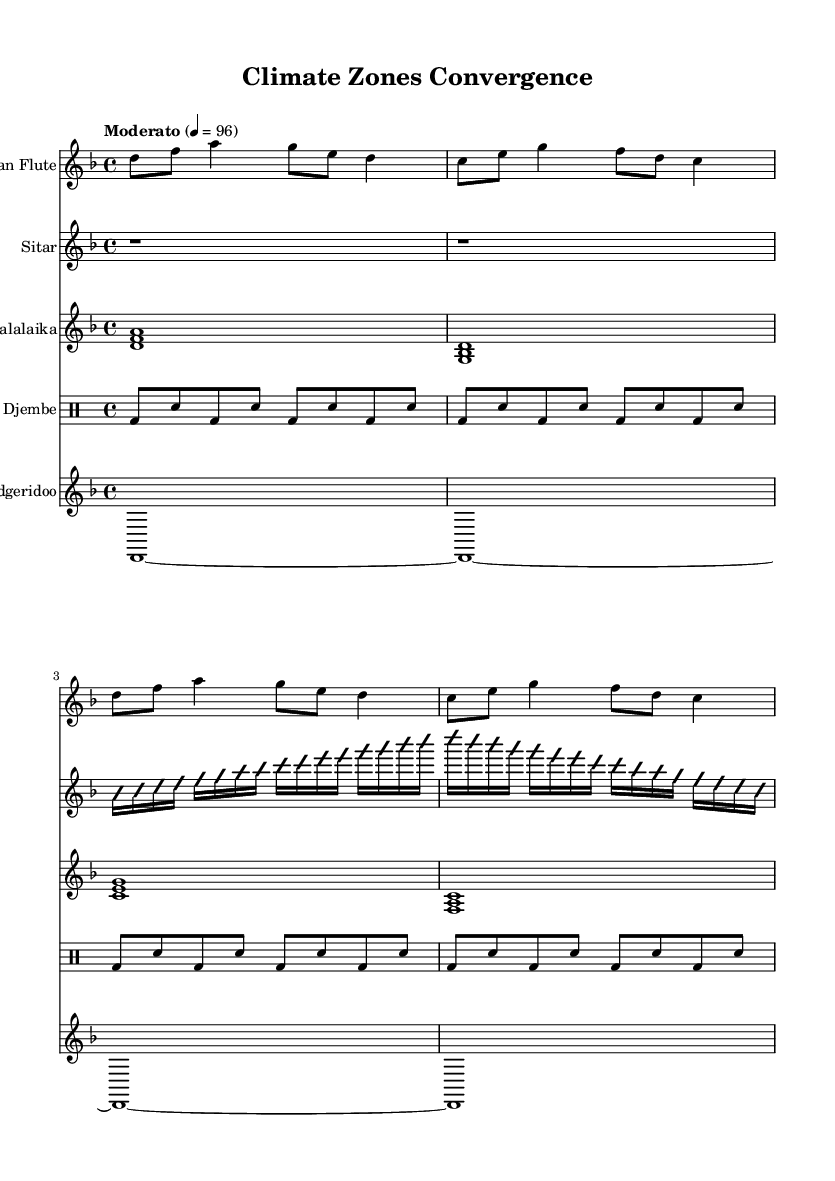What is the key signature of this music? The key signature is D minor, which contains one flat (B flat).
Answer: D minor What is the time signature of the piece? The time signature is 4/4, meaning there are four beats in each measure.
Answer: 4/4 What is the tempo marking indicated in the sheet music? The tempo is marked as "Moderato," which typically indicates a moderate speed.
Answer: Moderato How many different instruments are used in this composition? There are five instruments: pan flute, sitar, balalaika, djembe, and didgeridoo.
Answer: Five Which instrument has a drum pattern, and what is it called? The djembe has a specified drum pattern, identified by the notation unique to percussion instruments.
Answer: Djembe What texture does the sitar part suggest in the music? The sitar part indicates an improvisational texture, as denoted by the "improvisationOn" and "improvisationOff" markings.
Answer: Improvisational Which indigenous instrument represents the Australian climate zone? The didgeridoo is recognized as the indigenous instrument associated with the Australian climate zone.
Answer: Didgeridoo 